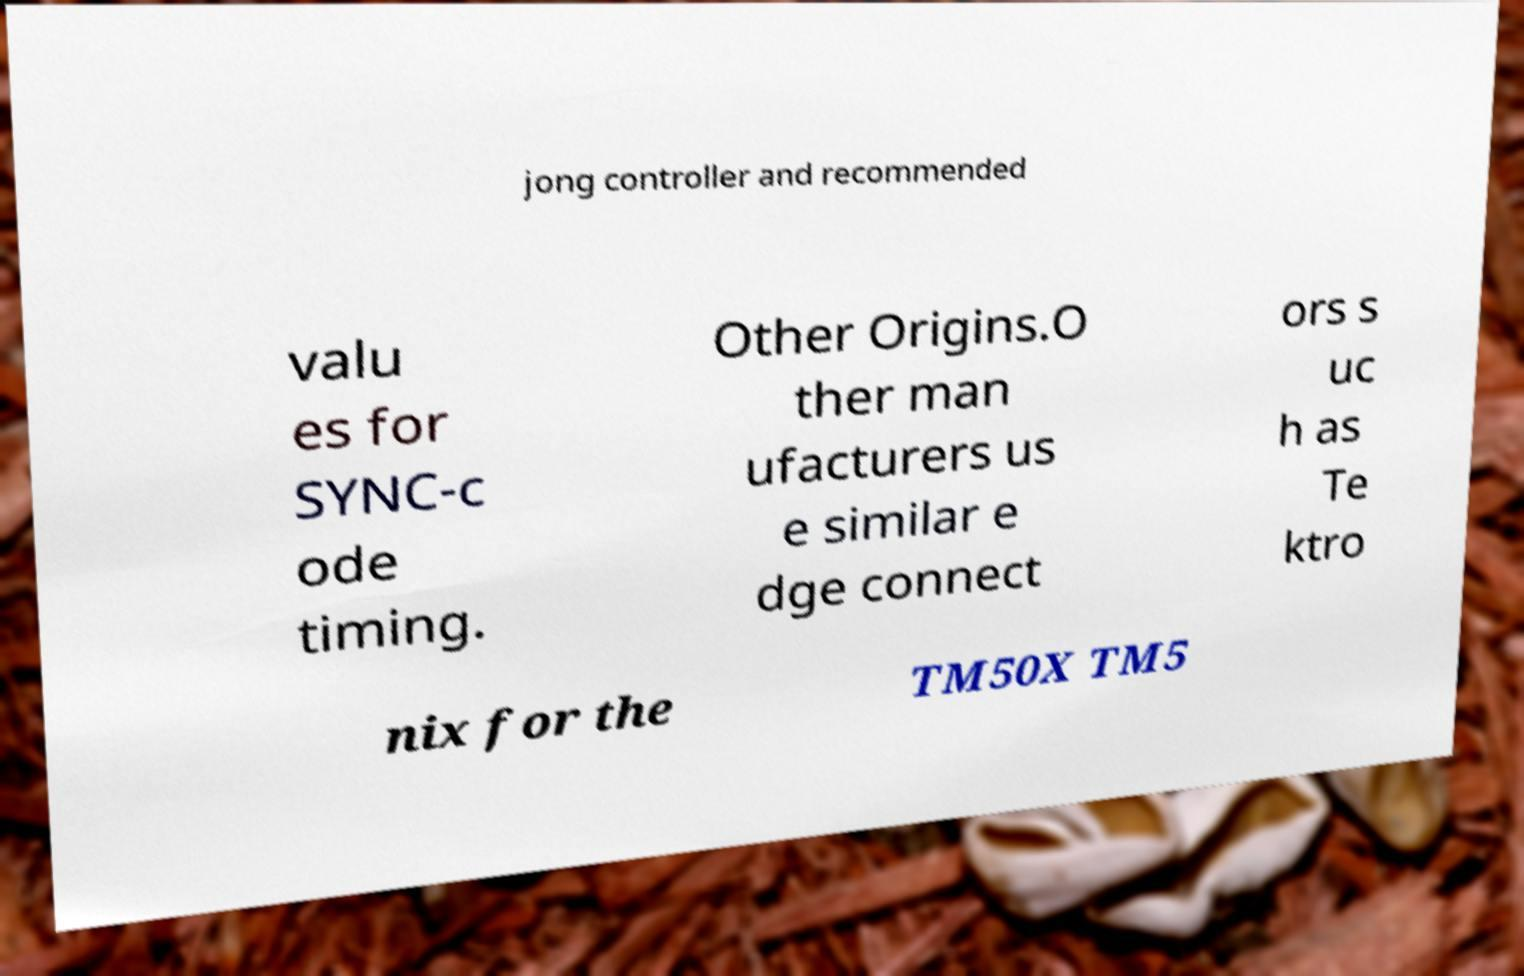For documentation purposes, I need the text within this image transcribed. Could you provide that? jong controller and recommended valu es for SYNC-c ode timing. Other Origins.O ther man ufacturers us e similar e dge connect ors s uc h as Te ktro nix for the TM50X TM5 